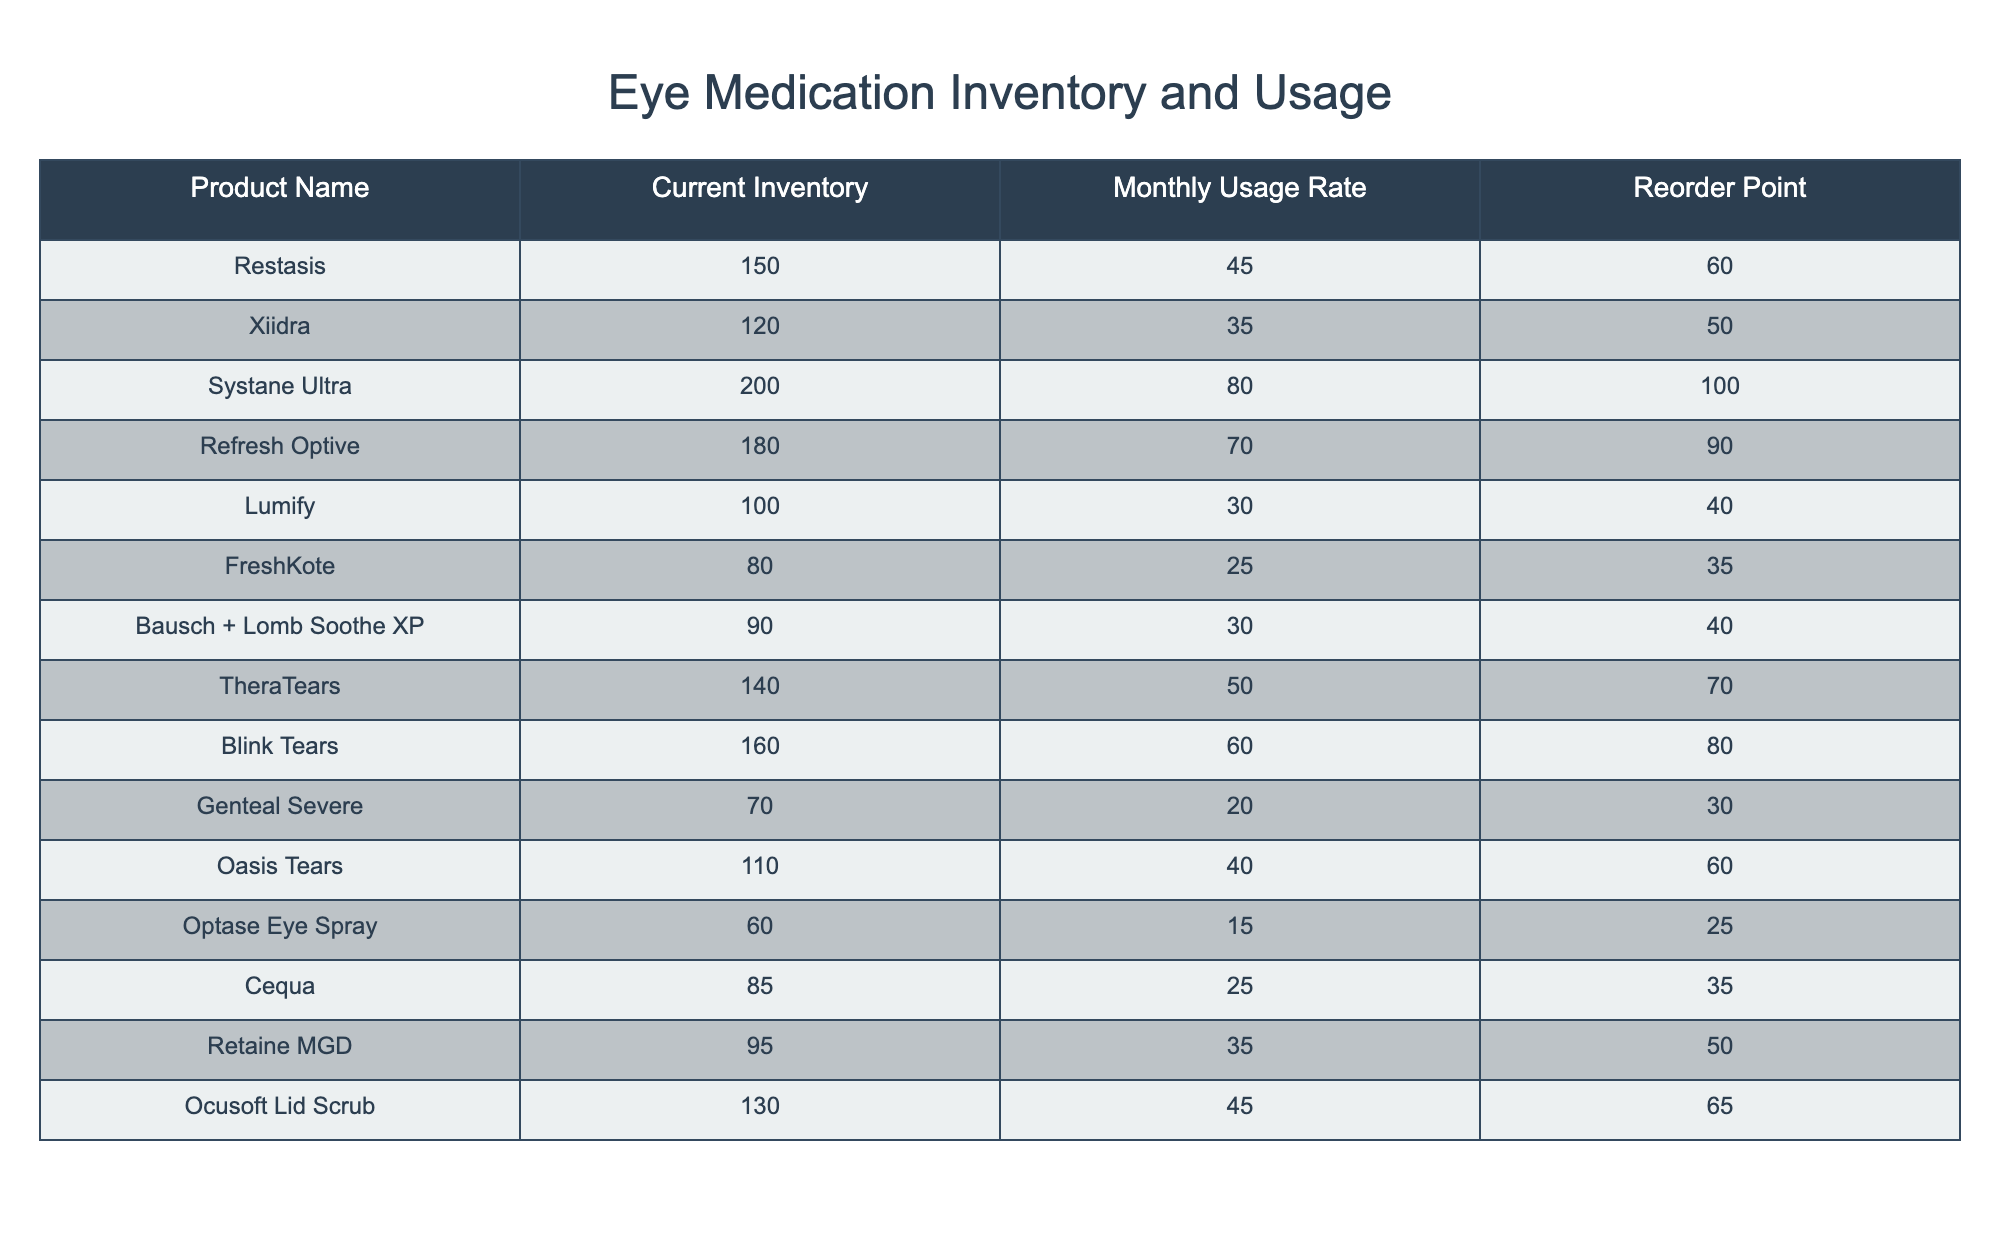What is the current inventory of Systane Ultra? The table provides the current inventory for each product. For Systane Ultra, the entry shows a current inventory of 200.
Answer: 200 What is the monthly usage rate of Blink Tears? By checking the table, we see that the monthly usage rate for Blink Tears is listed as 60.
Answer: 60 Is the reorder point for FreshKote lower than that for Lumify? The reorder point for FreshKote is 35, while for Lumify it is 40. Since 35 is less than 40, the statement is true.
Answer: Yes What is the total monthly usage rate for all medications listed in the table? We need to sum the monthly usage rates for all products: 45 + 35 + 80 + 70 + 30 + 25 + 30 + 50 + 60 + 20 + 40 + 15 + 25 + 35 + 45 = 585.
Answer: 585 Which product has the highest current inventory, and what is that amount? Looking at the current inventory column, Systane Ultra has the highest value at 200.
Answer: Systane Ultra, 200 What is the difference in monthly usage rates between Restasis and Retaine MGD? Restasis has a monthly usage rate of 45 and Retaine MGD has 35. The difference is 45 - 35 = 10.
Answer: 10 Are there any products with a current inventory below their reorder point? Checking the table, FreshKote has a current inventory of 80, which is greater than its reorder point of 35. All other products also have inventories higher than their respective reorder points. Therefore, there are no products below their reorder points.
Answer: No What is the average current inventory of the products listed? The current inventory amounts total to 150 + 120 + 200 + 180 + 100 + 80 + 90 + 140 + 160 + 70 + 110 + 60 + 85 + 95 + 130 = 1,545. There are 15 products, so the average is 1,545 / 15 = 103.
Answer: 103 Which product has the lowest monthly usage rate, and what is that rate? Inspecting the monthly usage rate column, Genteal Severe shows a usage rate of 20, which is the lowest.
Answer: Genteal Severe, 20 